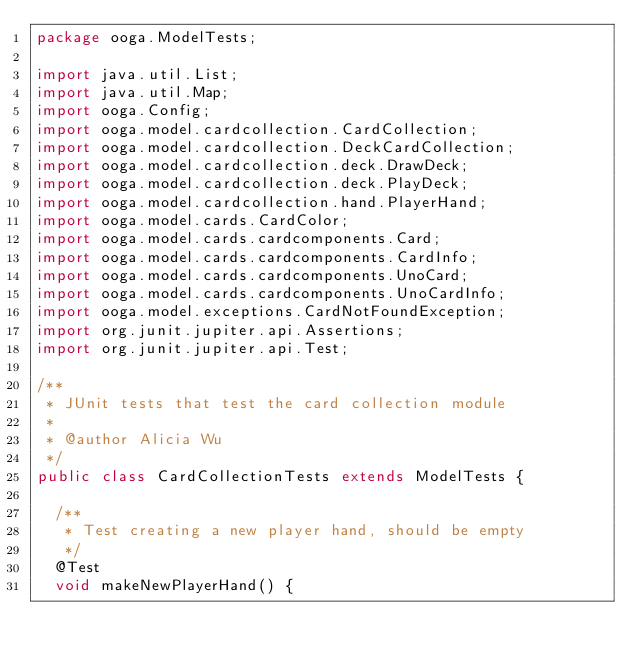<code> <loc_0><loc_0><loc_500><loc_500><_Java_>package ooga.ModelTests;

import java.util.List;
import java.util.Map;
import ooga.Config;
import ooga.model.cardcollection.CardCollection;
import ooga.model.cardcollection.DeckCardCollection;
import ooga.model.cardcollection.deck.DrawDeck;
import ooga.model.cardcollection.deck.PlayDeck;
import ooga.model.cardcollection.hand.PlayerHand;
import ooga.model.cards.CardColor;
import ooga.model.cards.cardcomponents.Card;
import ooga.model.cards.cardcomponents.CardInfo;
import ooga.model.cards.cardcomponents.UnoCard;
import ooga.model.cards.cardcomponents.UnoCardInfo;
import ooga.model.exceptions.CardNotFoundException;
import org.junit.jupiter.api.Assertions;
import org.junit.jupiter.api.Test;

/**
 * JUnit tests that test the card collection module
 *
 * @author Alicia Wu
 */
public class CardCollectionTests extends ModelTests {

  /**
   * Test creating a new player hand, should be empty
   */
  @Test
  void makeNewPlayerHand() {</code> 